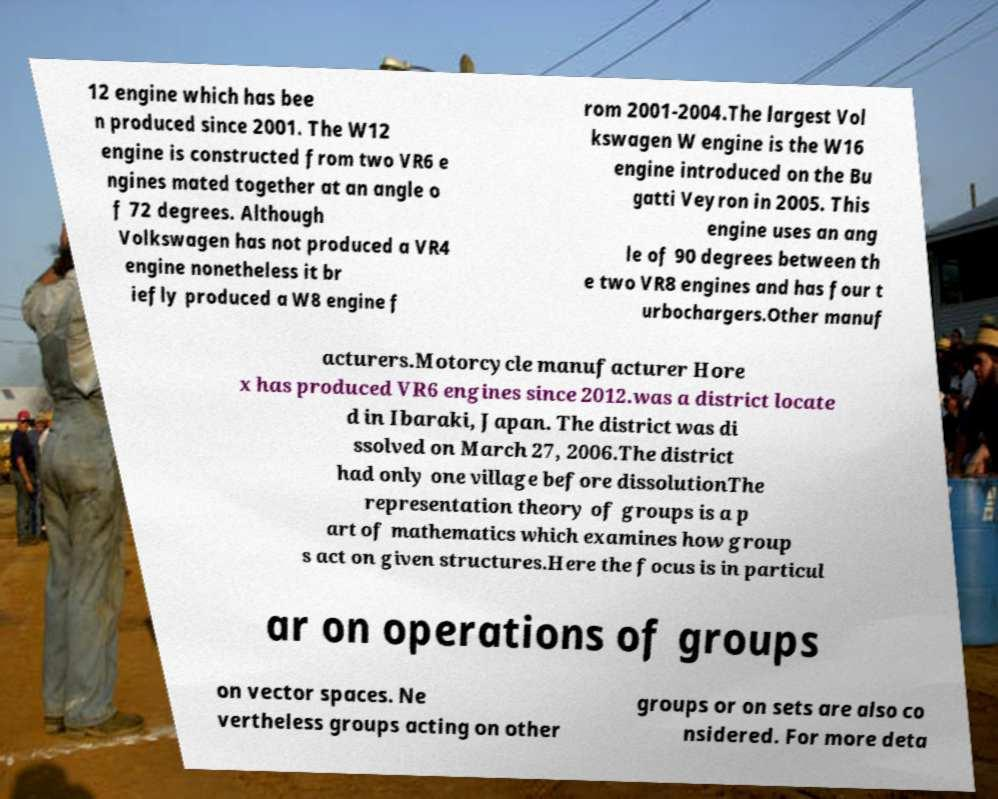What messages or text are displayed in this image? I need them in a readable, typed format. 12 engine which has bee n produced since 2001. The W12 engine is constructed from two VR6 e ngines mated together at an angle o f 72 degrees. Although Volkswagen has not produced a VR4 engine nonetheless it br iefly produced a W8 engine f rom 2001-2004.The largest Vol kswagen W engine is the W16 engine introduced on the Bu gatti Veyron in 2005. This engine uses an ang le of 90 degrees between th e two VR8 engines and has four t urbochargers.Other manuf acturers.Motorcycle manufacturer Hore x has produced VR6 engines since 2012.was a district locate d in Ibaraki, Japan. The district was di ssolved on March 27, 2006.The district had only one village before dissolutionThe representation theory of groups is a p art of mathematics which examines how group s act on given structures.Here the focus is in particul ar on operations of groups on vector spaces. Ne vertheless groups acting on other groups or on sets are also co nsidered. For more deta 